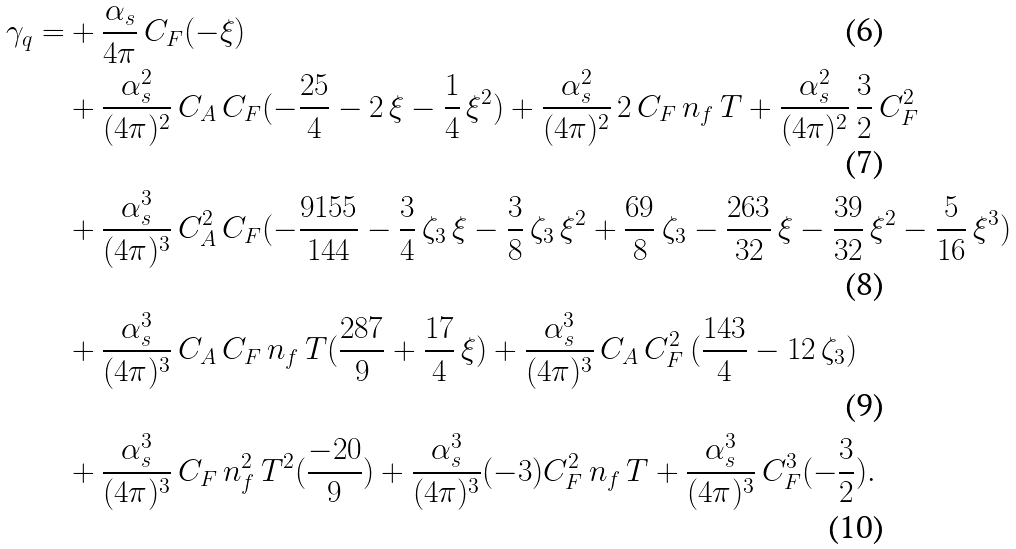<formula> <loc_0><loc_0><loc_500><loc_500>\gamma _ { q } = & + \frac { \alpha _ { s } } { 4 \pi } \, C _ { F } ( - \xi ) \\ & + \frac { \alpha _ { s } ^ { 2 } } { ( 4 \pi ) ^ { 2 } } \, C _ { A } \, C _ { F } ( - \frac { 2 5 } { 4 } - 2 \, \xi - \frac { 1 } { 4 } \, \xi ^ { 2 } ) + \frac { \alpha _ { s } ^ { 2 } } { ( 4 \pi ) ^ { 2 } } \, 2 \, C _ { F } \, n _ { f } \, T + \frac { \alpha _ { s } ^ { 2 } } { ( 4 \pi ) ^ { 2 } } \, \frac { 3 } { 2 } \, C _ { F } ^ { 2 } \\ & + \frac { \alpha _ { s } ^ { 3 } } { ( 4 \pi ) ^ { 3 } } \, C _ { A } ^ { 2 } \, C _ { F } ( - \frac { 9 1 5 5 } { 1 4 4 } - \frac { 3 } { 4 } \, \zeta _ { 3 } \, \xi - \frac { 3 } { 8 } \, \zeta _ { 3 } \, \xi ^ { 2 } + \frac { 6 9 } { 8 } \, \zeta _ { 3 } - \frac { 2 6 3 } { 3 2 } \, \xi - \frac { 3 9 } { 3 2 } \, \xi ^ { 2 } - \frac { 5 } { 1 6 } \, \xi ^ { 3 } ) \\ & + \frac { \alpha _ { s } ^ { 3 } } { ( 4 \pi ) ^ { 3 } } \, C _ { A } \, C _ { F } \, n _ { f } \, T ( \frac { 2 8 7 } { 9 } + \frac { 1 7 } { 4 } \, \xi ) + \frac { \alpha _ { s } ^ { 3 } } { ( 4 \pi ) ^ { 3 } } \, C _ { A } \, C _ { F } ^ { 2 } \, ( \frac { 1 4 3 } { 4 } - 1 2 \, \zeta _ { 3 } ) \\ & + \frac { \alpha _ { s } ^ { 3 } } { ( 4 \pi ) ^ { 3 } } \, C _ { F } \, n _ { f } ^ { 2 } \, T ^ { 2 } ( \frac { - 2 0 } { 9 } ) + \frac { \alpha _ { s } ^ { 3 } } { ( 4 \pi ) ^ { 3 } } ( - 3 ) C _ { F } ^ { 2 } \, n _ { f } \, T + \frac { \alpha _ { s } ^ { 3 } } { ( 4 \pi ) ^ { 3 } } \, C _ { F } ^ { 3 } ( - \frac { 3 } { 2 } ) .</formula> 